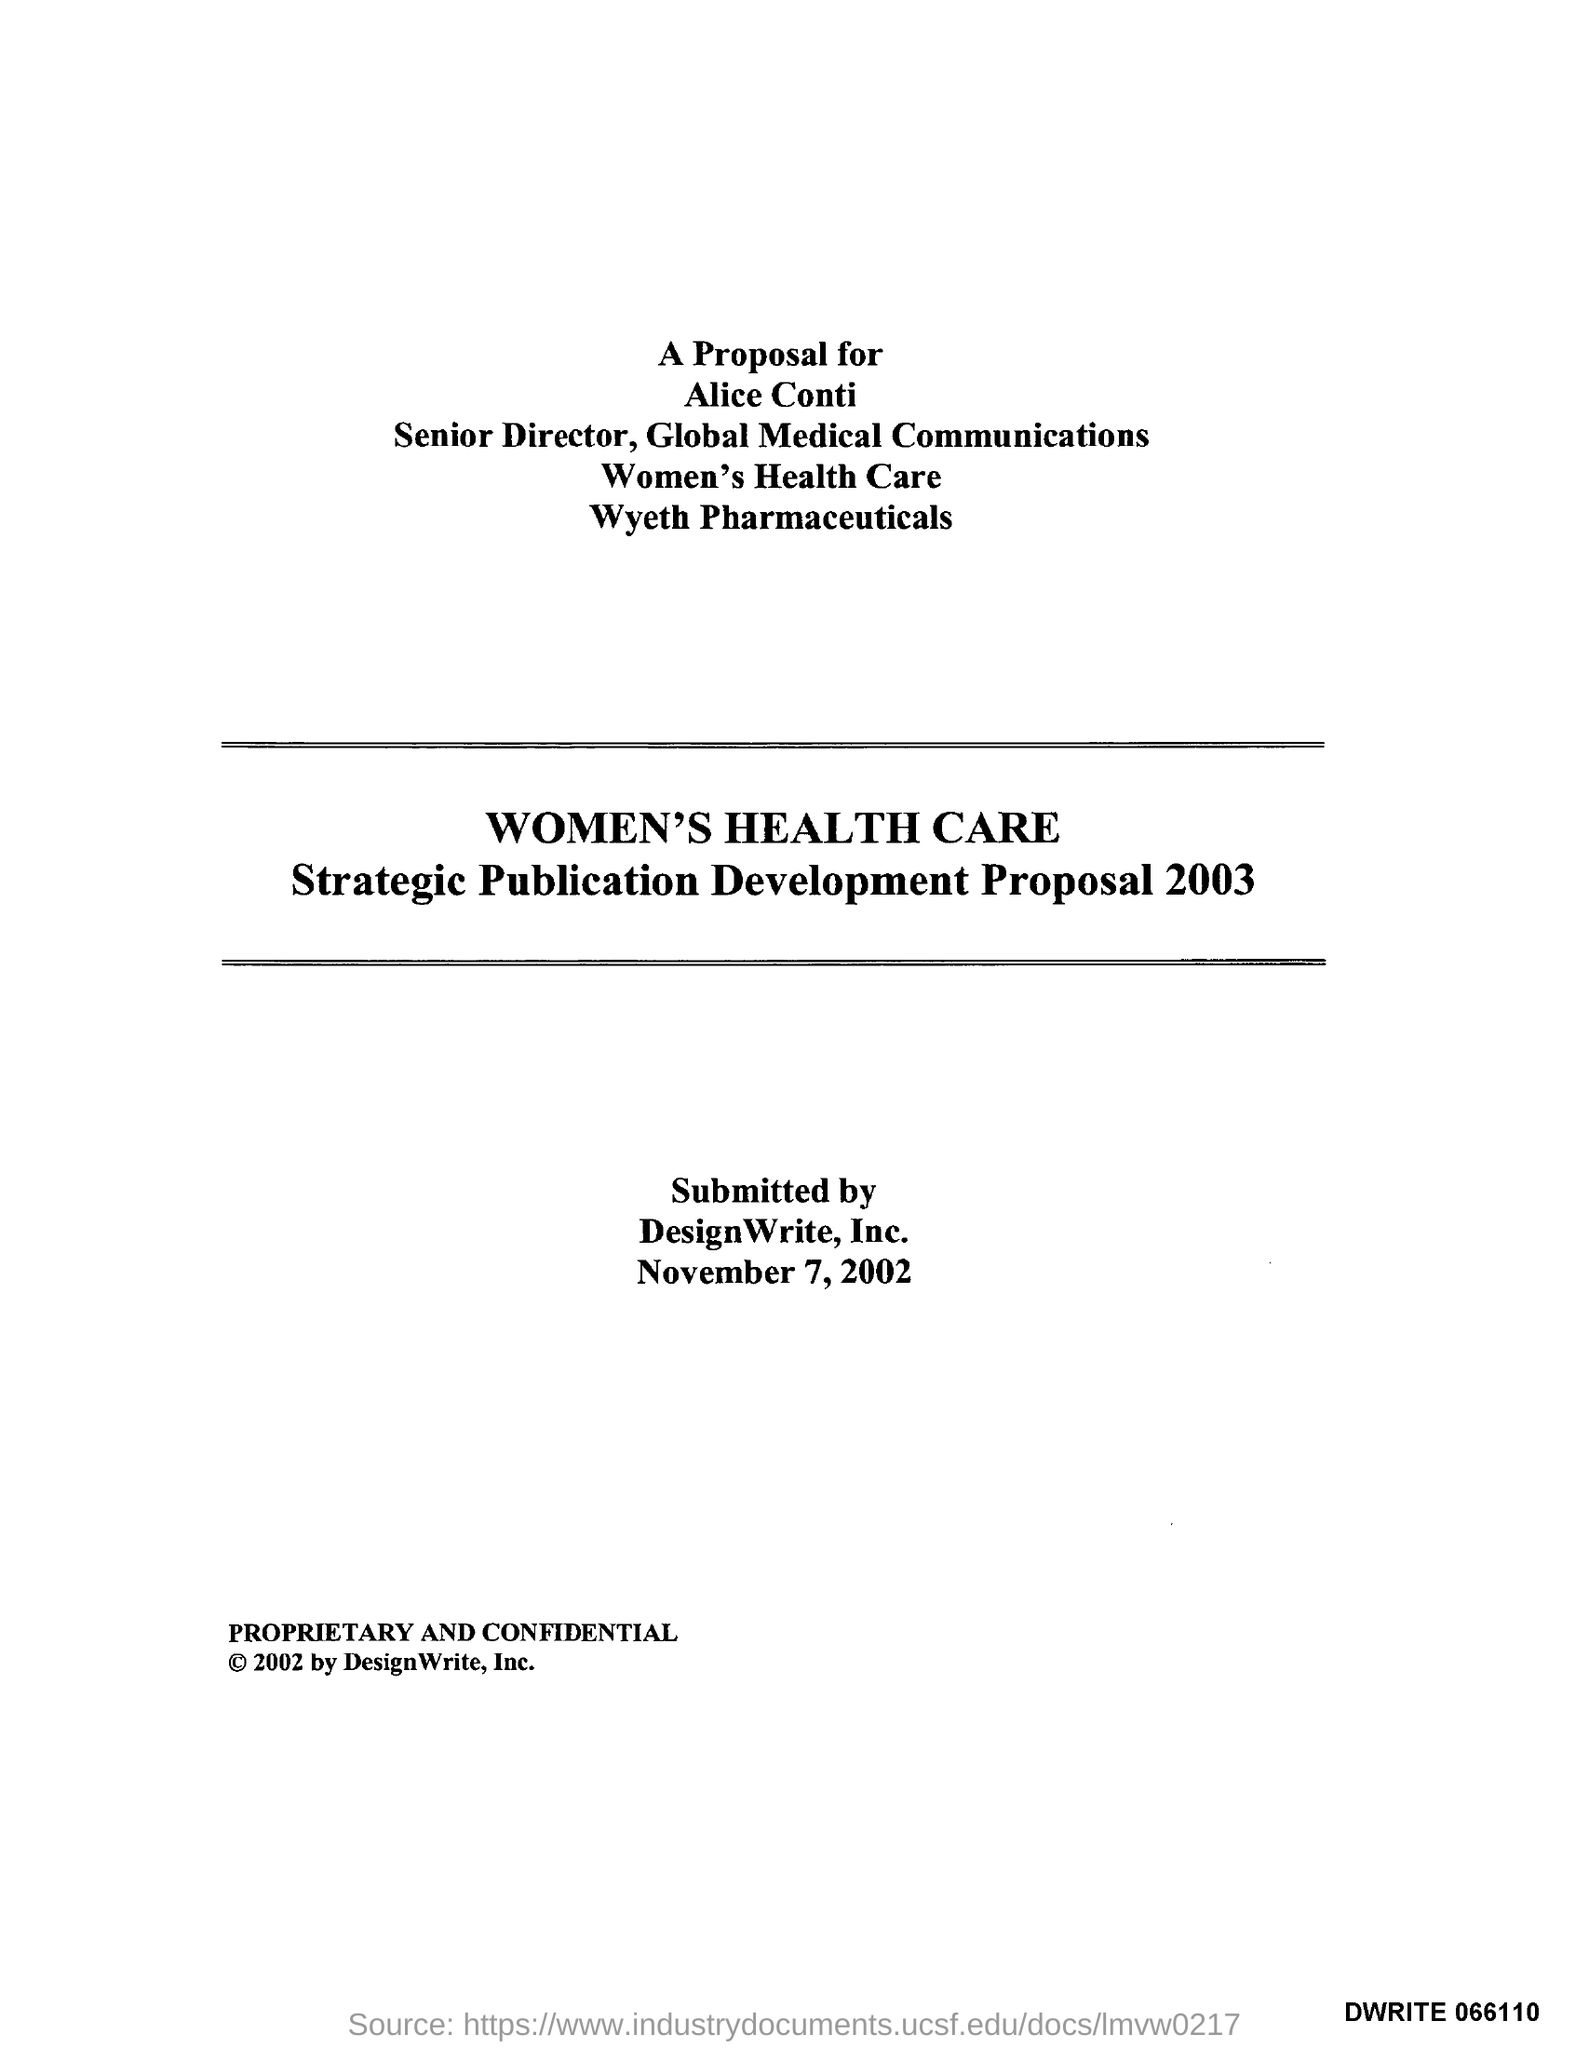Draw attention to some important aspects in this diagram. The date on the document is November 7, 2002. 